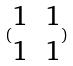Convert formula to latex. <formula><loc_0><loc_0><loc_500><loc_500>( \begin{matrix} 1 & 1 \\ 1 & 1 \end{matrix} )</formula> 